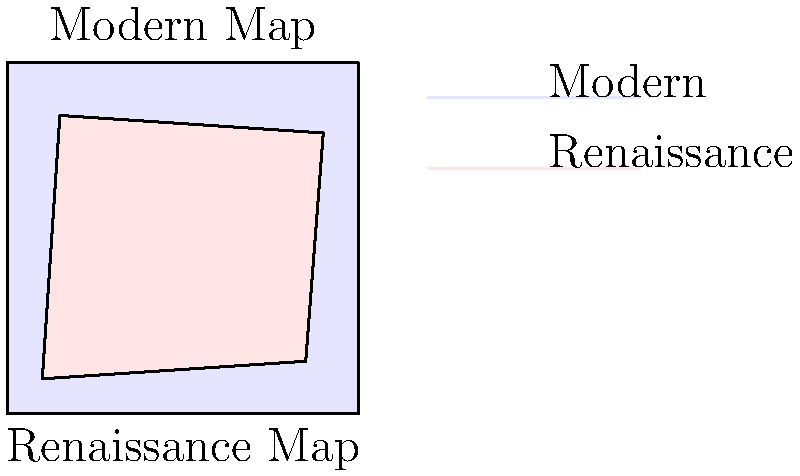Based on the diagram comparing a Renaissance world map to a modern satellite-derived map, estimate the percentage of accuracy of the Renaissance map in terms of landmass shape and position. Consider factors such as coastline deviations, continental positioning, and overall proportions. To estimate the accuracy of the Renaissance map compared to the modern satellite-derived map, we need to analyze several factors:

1. Overall shape: The Renaissance map shows a rough approximation of the modern map's shape, but with significant deviations.

2. Coastline accuracy: The Renaissance map's coastlines are notably different from the modern map, with exaggerated curves and inaccurate bays.

3. Continental positioning: While the general placement of landmasses is present, there are clear discrepancies in their relative positions.

4. Proportions: The Renaissance map shows distortions in the size and proportions of landmasses compared to the modern map.

5. Coverage: The Renaissance map appears to cover most of the known world at the time, but likely misses or misrepresents some areas due to limited exploration.

Considering these factors:
- The basic shape is recognizable, giving a base accuracy of about 60%.
- Coastline inaccuracies reduce this by about 10%.
- Positioning errors account for another 5% reduction.
- Proportion distortions further decrease accuracy by about 5%.

Therefore, we can estimate the overall accuracy to be approximately 40% compared to the modern satellite-derived map.

It's important to note that this accuracy is remarkably high for the time, given the limited tools and knowledge available to Renaissance cartographers.
Answer: Approximately 40% accurate 